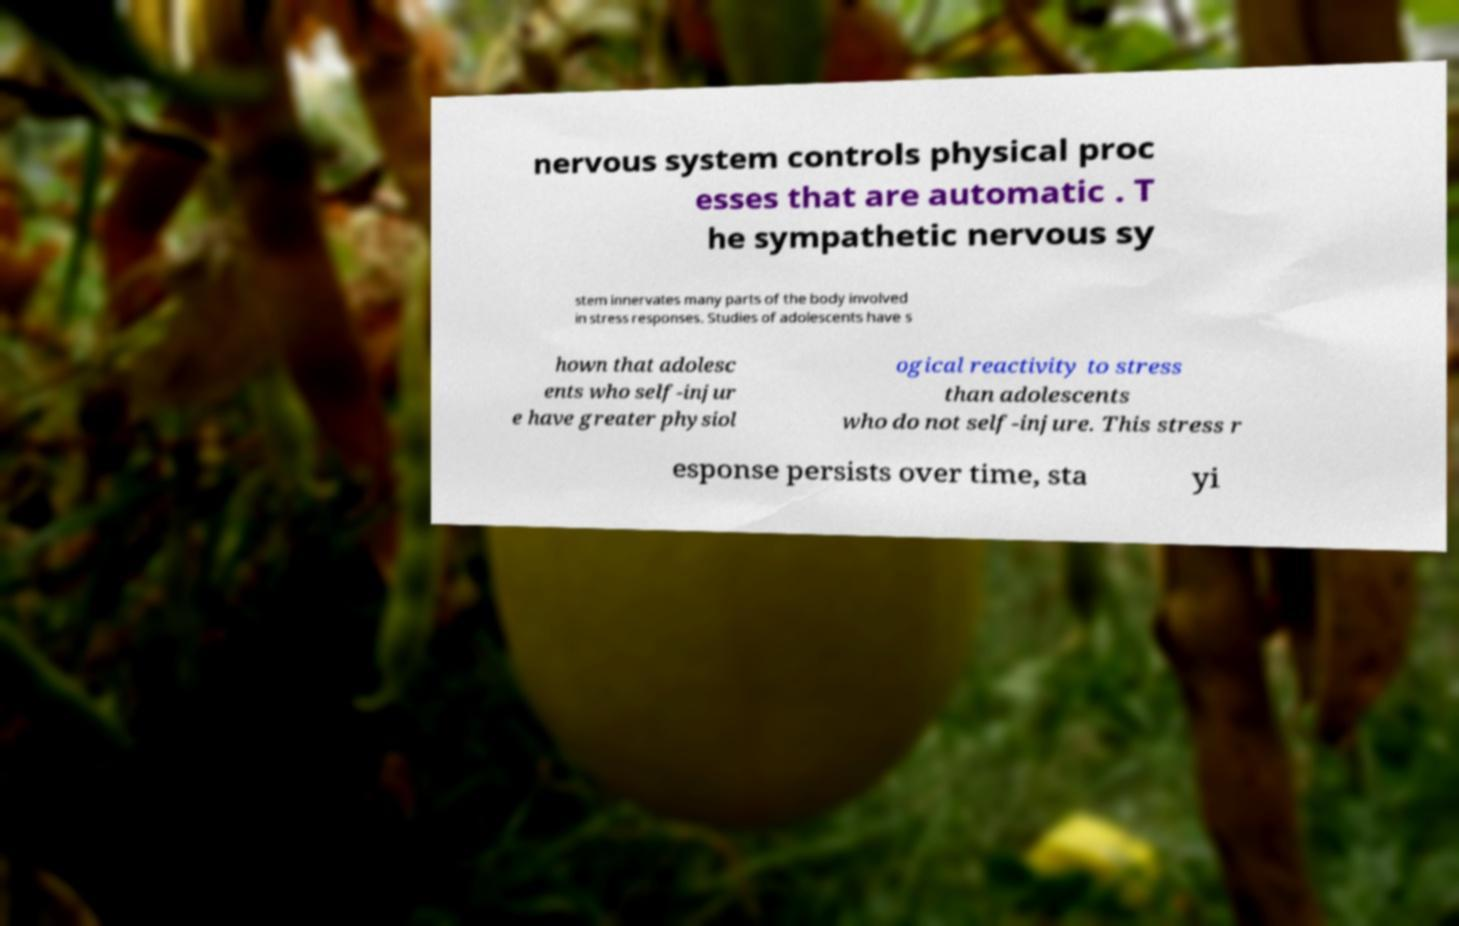Please identify and transcribe the text found in this image. nervous system controls physical proc esses that are automatic . T he sympathetic nervous sy stem innervates many parts of the body involved in stress responses. Studies of adolescents have s hown that adolesc ents who self-injur e have greater physiol ogical reactivity to stress than adolescents who do not self-injure. This stress r esponse persists over time, sta yi 